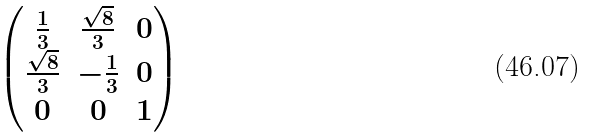<formula> <loc_0><loc_0><loc_500><loc_500>\begin{pmatrix} \frac { 1 } { 3 } & \frac { \sqrt { 8 } } { 3 } & 0 \\ \frac { \sqrt { 8 } } { 3 } & - \frac { 1 } { 3 } & 0 \\ 0 & 0 & 1 \\ \end{pmatrix}</formula> 